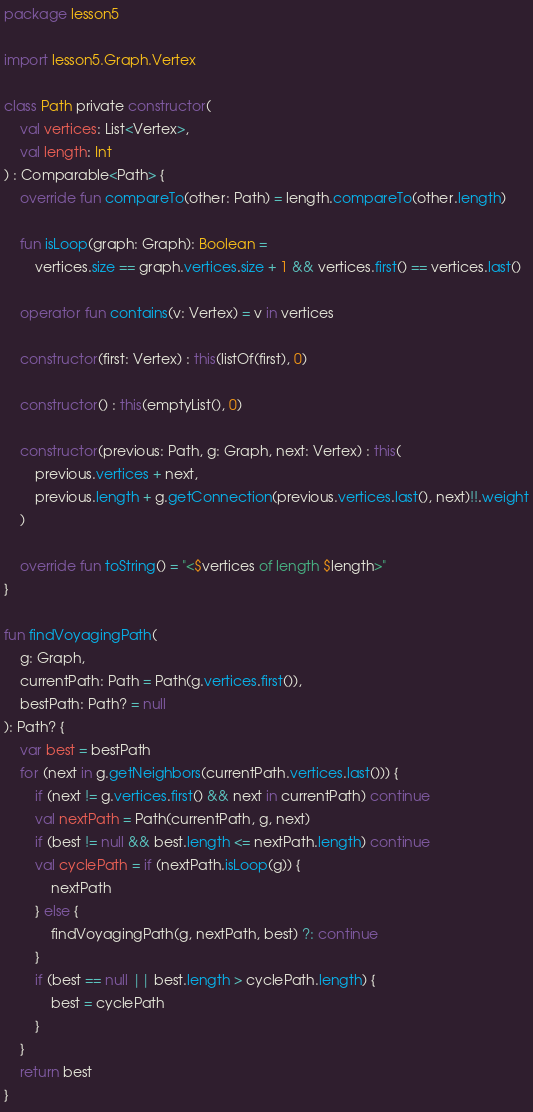<code> <loc_0><loc_0><loc_500><loc_500><_Kotlin_>package lesson5

import lesson5.Graph.Vertex

class Path private constructor(
    val vertices: List<Vertex>,
    val length: Int
) : Comparable<Path> {
    override fun compareTo(other: Path) = length.compareTo(other.length)

    fun isLoop(graph: Graph): Boolean =
        vertices.size == graph.vertices.size + 1 && vertices.first() == vertices.last()

    operator fun contains(v: Vertex) = v in vertices

    constructor(first: Vertex) : this(listOf(first), 0)

    constructor() : this(emptyList(), 0)

    constructor(previous: Path, g: Graph, next: Vertex) : this(
        previous.vertices + next,
        previous.length + g.getConnection(previous.vertices.last(), next)!!.weight
    )

    override fun toString() = "<$vertices of length $length>"
}

fun findVoyagingPath(
    g: Graph,
    currentPath: Path = Path(g.vertices.first()),
    bestPath: Path? = null
): Path? {
    var best = bestPath
    for (next in g.getNeighbors(currentPath.vertices.last())) {
        if (next != g.vertices.first() && next in currentPath) continue
        val nextPath = Path(currentPath, g, next)
        if (best != null && best.length <= nextPath.length) continue
        val cyclePath = if (nextPath.isLoop(g)) {
            nextPath
        } else {
            findVoyagingPath(g, nextPath, best) ?: continue
        }
        if (best == null || best.length > cyclePath.length) {
            best = cyclePath
        }
    }
    return best
}
</code> 